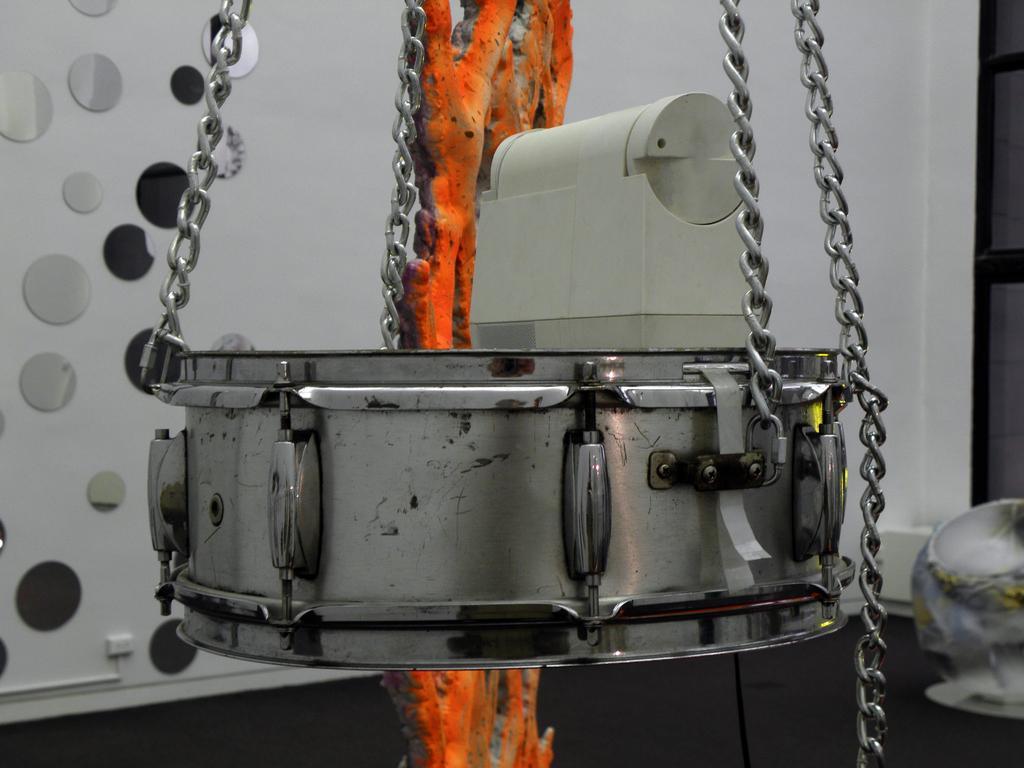Could you give a brief overview of what you see in this image? In this image I can see a snare drum like metal object hanging through the chains and I can see a designed wall as the background. I can see another device on this drum and I can see a cloth-like structure hanging behind the drum. 